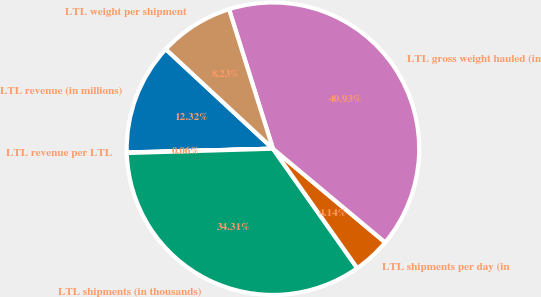<chart> <loc_0><loc_0><loc_500><loc_500><pie_chart><fcel>LTL revenue (in millions)<fcel>LTL revenue per LTL<fcel>LTL shipments (in thousands)<fcel>LTL shipments per day (in<fcel>LTL gross weight hauled (in<fcel>LTL weight per shipment<nl><fcel>12.32%<fcel>0.06%<fcel>34.31%<fcel>4.14%<fcel>40.93%<fcel>8.23%<nl></chart> 